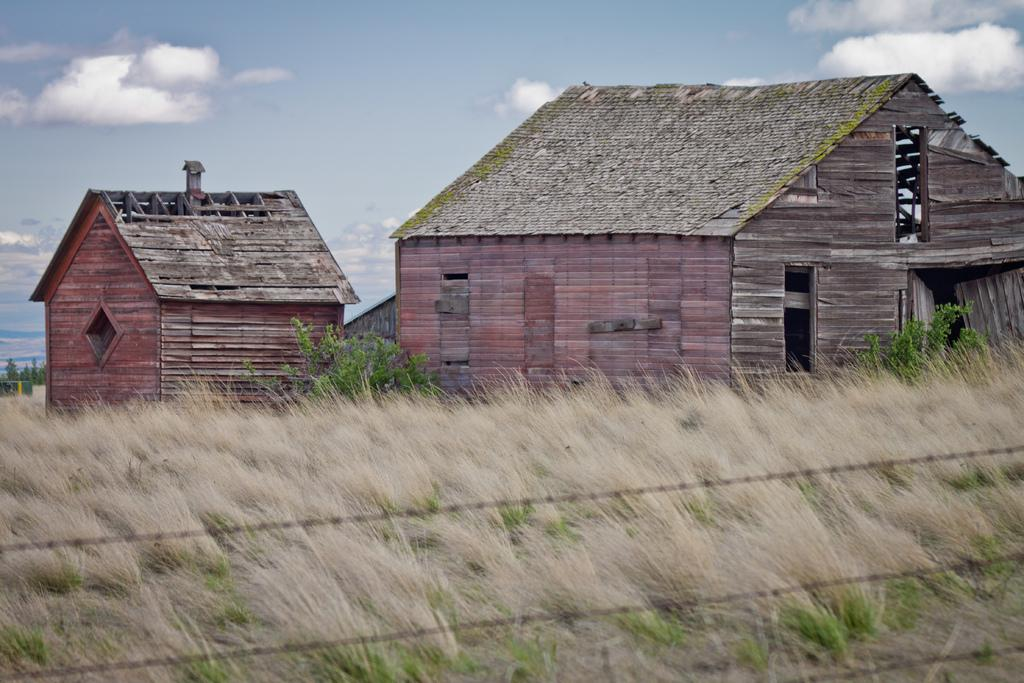What type of houses can be seen in the image? There are wooden houses in the image. What is the ground surface like in the image? There is grass visible in the image. Are there any plants in the image? Yes, there are plants in the image. How would you describe the sky in the image? The sky is blue and cloudy in the image. What thrilling space adventure is the father embarking on in the image? There is no father or space adventure present in the image; it features wooden houses, grass, plants, and a blue, cloudy sky. 